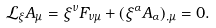<formula> <loc_0><loc_0><loc_500><loc_500>\mathcal { L } _ { \xi } A _ { \mu } = \xi ^ { \nu } F _ { \nu \mu } + ( \xi ^ { \alpha } A _ { \alpha } ) _ { , \mu } = 0 .</formula> 